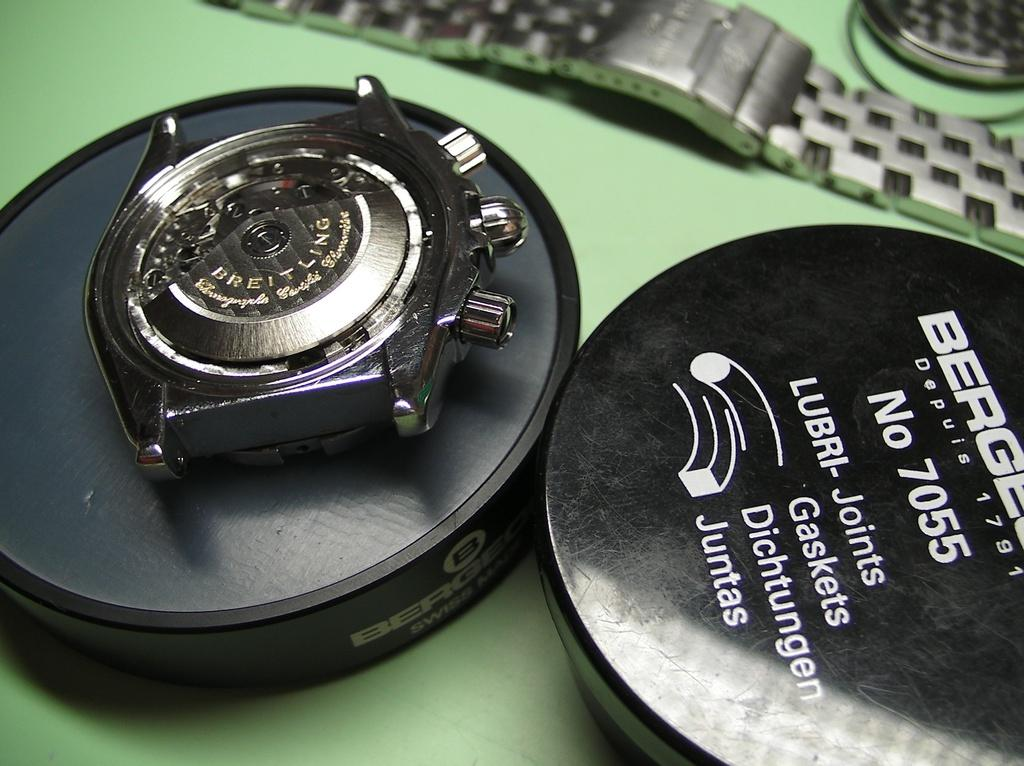<image>
Create a compact narrative representing the image presented. The backside of a Breitling wristwatch is shown in its box. 